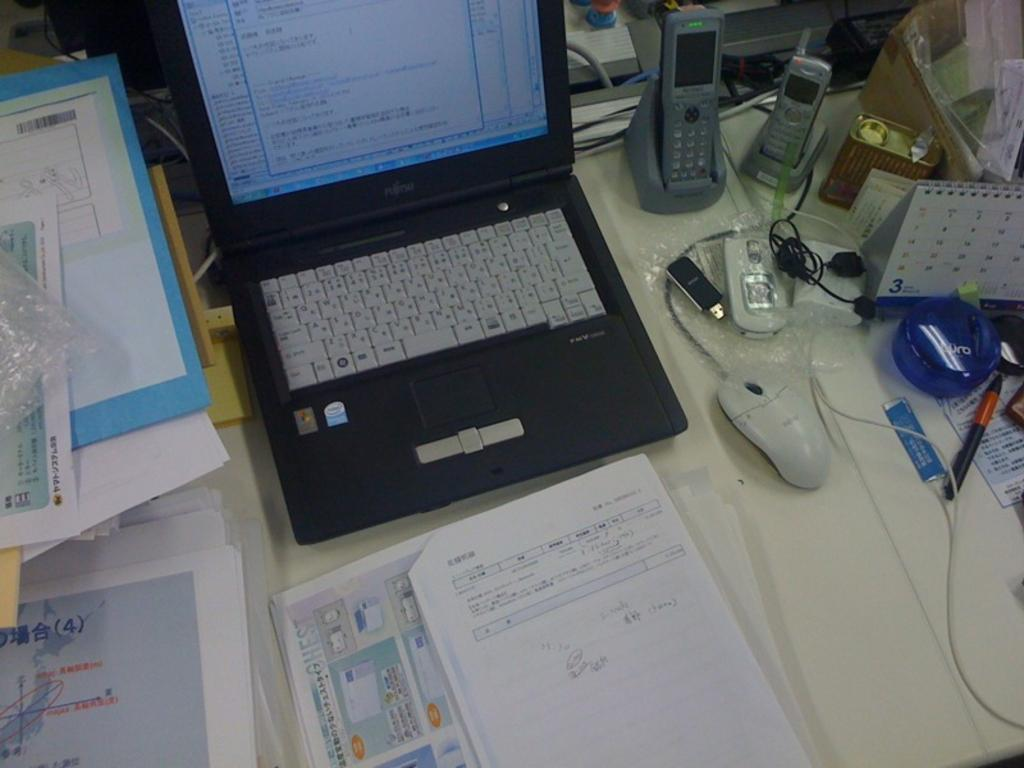Provide a one-sentence caption for the provided image. A calendar on the right of a laptop with the number 3 at the bottom left of it. 